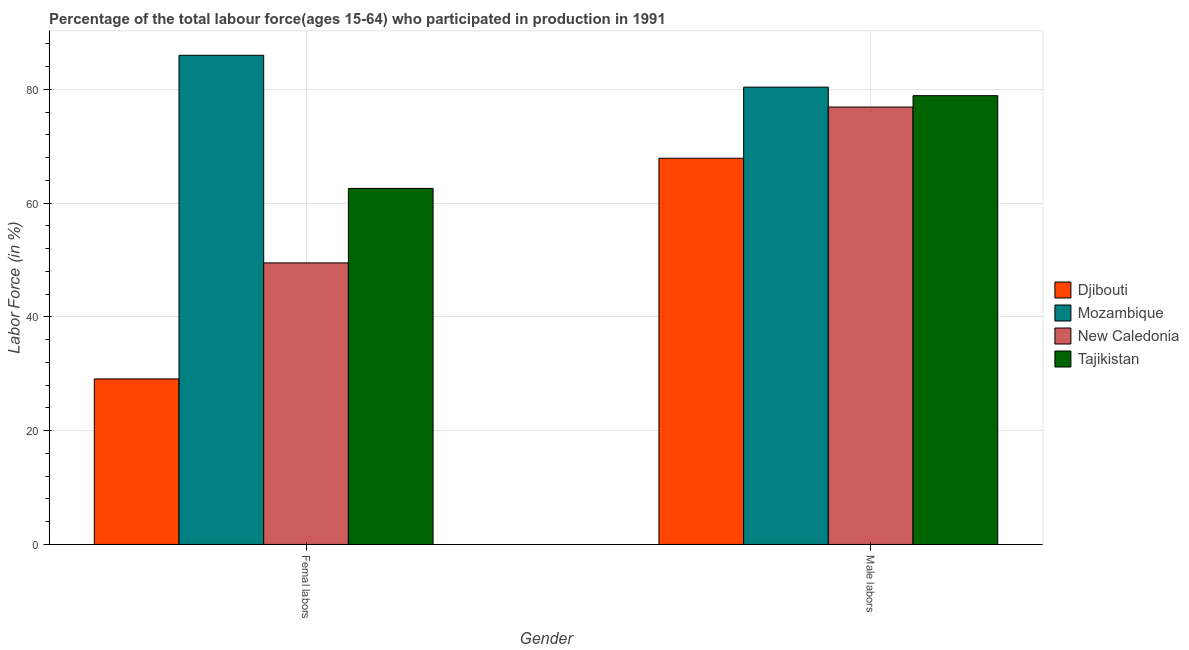How many different coloured bars are there?
Make the answer very short. 4. Are the number of bars on each tick of the X-axis equal?
Offer a terse response. Yes. How many bars are there on the 2nd tick from the right?
Your response must be concise. 4. What is the label of the 2nd group of bars from the left?
Your response must be concise. Male labors. What is the percentage of female labor force in Mozambique?
Provide a succinct answer. 86. Across all countries, what is the maximum percentage of female labor force?
Ensure brevity in your answer.  86. Across all countries, what is the minimum percentage of male labour force?
Provide a succinct answer. 67.9. In which country was the percentage of male labour force maximum?
Provide a succinct answer. Mozambique. In which country was the percentage of male labour force minimum?
Provide a succinct answer. Djibouti. What is the total percentage of male labour force in the graph?
Your answer should be very brief. 304.1. What is the difference between the percentage of female labor force in Tajikistan and that in Djibouti?
Provide a short and direct response. 33.5. What is the difference between the percentage of male labour force in New Caledonia and the percentage of female labor force in Mozambique?
Your response must be concise. -9.1. What is the average percentage of male labour force per country?
Give a very brief answer. 76.03. What is the difference between the percentage of female labor force and percentage of male labour force in Mozambique?
Your response must be concise. 5.6. What is the ratio of the percentage of female labor force in Mozambique to that in Tajikistan?
Offer a terse response. 1.37. Is the percentage of female labor force in Djibouti less than that in New Caledonia?
Keep it short and to the point. Yes. In how many countries, is the percentage of female labor force greater than the average percentage of female labor force taken over all countries?
Offer a terse response. 2. What does the 4th bar from the left in Male labors represents?
Give a very brief answer. Tajikistan. What does the 3rd bar from the right in Male labors represents?
Offer a terse response. Mozambique. How many countries are there in the graph?
Ensure brevity in your answer.  4. Are the values on the major ticks of Y-axis written in scientific E-notation?
Offer a terse response. No. Does the graph contain any zero values?
Your answer should be compact. No. Does the graph contain grids?
Make the answer very short. Yes. How are the legend labels stacked?
Ensure brevity in your answer.  Vertical. What is the title of the graph?
Offer a very short reply. Percentage of the total labour force(ages 15-64) who participated in production in 1991. Does "Armenia" appear as one of the legend labels in the graph?
Offer a terse response. No. What is the label or title of the X-axis?
Provide a succinct answer. Gender. What is the Labor Force (in %) in Djibouti in Femal labors?
Give a very brief answer. 29.1. What is the Labor Force (in %) in Mozambique in Femal labors?
Ensure brevity in your answer.  86. What is the Labor Force (in %) of New Caledonia in Femal labors?
Offer a terse response. 49.5. What is the Labor Force (in %) of Tajikistan in Femal labors?
Offer a very short reply. 62.6. What is the Labor Force (in %) of Djibouti in Male labors?
Offer a very short reply. 67.9. What is the Labor Force (in %) in Mozambique in Male labors?
Provide a short and direct response. 80.4. What is the Labor Force (in %) of New Caledonia in Male labors?
Offer a terse response. 76.9. What is the Labor Force (in %) of Tajikistan in Male labors?
Your response must be concise. 78.9. Across all Gender, what is the maximum Labor Force (in %) in Djibouti?
Provide a short and direct response. 67.9. Across all Gender, what is the maximum Labor Force (in %) in Mozambique?
Provide a succinct answer. 86. Across all Gender, what is the maximum Labor Force (in %) of New Caledonia?
Provide a short and direct response. 76.9. Across all Gender, what is the maximum Labor Force (in %) in Tajikistan?
Your answer should be very brief. 78.9. Across all Gender, what is the minimum Labor Force (in %) in Djibouti?
Provide a succinct answer. 29.1. Across all Gender, what is the minimum Labor Force (in %) in Mozambique?
Give a very brief answer. 80.4. Across all Gender, what is the minimum Labor Force (in %) of New Caledonia?
Your response must be concise. 49.5. Across all Gender, what is the minimum Labor Force (in %) of Tajikistan?
Your response must be concise. 62.6. What is the total Labor Force (in %) of Djibouti in the graph?
Offer a terse response. 97. What is the total Labor Force (in %) of Mozambique in the graph?
Your answer should be very brief. 166.4. What is the total Labor Force (in %) in New Caledonia in the graph?
Provide a short and direct response. 126.4. What is the total Labor Force (in %) in Tajikistan in the graph?
Provide a succinct answer. 141.5. What is the difference between the Labor Force (in %) of Djibouti in Femal labors and that in Male labors?
Keep it short and to the point. -38.8. What is the difference between the Labor Force (in %) in Mozambique in Femal labors and that in Male labors?
Ensure brevity in your answer.  5.6. What is the difference between the Labor Force (in %) in New Caledonia in Femal labors and that in Male labors?
Make the answer very short. -27.4. What is the difference between the Labor Force (in %) in Tajikistan in Femal labors and that in Male labors?
Provide a succinct answer. -16.3. What is the difference between the Labor Force (in %) of Djibouti in Femal labors and the Labor Force (in %) of Mozambique in Male labors?
Offer a very short reply. -51.3. What is the difference between the Labor Force (in %) of Djibouti in Femal labors and the Labor Force (in %) of New Caledonia in Male labors?
Offer a very short reply. -47.8. What is the difference between the Labor Force (in %) of Djibouti in Femal labors and the Labor Force (in %) of Tajikistan in Male labors?
Offer a very short reply. -49.8. What is the difference between the Labor Force (in %) of Mozambique in Femal labors and the Labor Force (in %) of Tajikistan in Male labors?
Your answer should be very brief. 7.1. What is the difference between the Labor Force (in %) of New Caledonia in Femal labors and the Labor Force (in %) of Tajikistan in Male labors?
Your response must be concise. -29.4. What is the average Labor Force (in %) of Djibouti per Gender?
Offer a very short reply. 48.5. What is the average Labor Force (in %) in Mozambique per Gender?
Offer a very short reply. 83.2. What is the average Labor Force (in %) in New Caledonia per Gender?
Provide a short and direct response. 63.2. What is the average Labor Force (in %) in Tajikistan per Gender?
Offer a terse response. 70.75. What is the difference between the Labor Force (in %) of Djibouti and Labor Force (in %) of Mozambique in Femal labors?
Give a very brief answer. -56.9. What is the difference between the Labor Force (in %) of Djibouti and Labor Force (in %) of New Caledonia in Femal labors?
Give a very brief answer. -20.4. What is the difference between the Labor Force (in %) of Djibouti and Labor Force (in %) of Tajikistan in Femal labors?
Offer a very short reply. -33.5. What is the difference between the Labor Force (in %) in Mozambique and Labor Force (in %) in New Caledonia in Femal labors?
Your answer should be very brief. 36.5. What is the difference between the Labor Force (in %) of Mozambique and Labor Force (in %) of Tajikistan in Femal labors?
Your answer should be very brief. 23.4. What is the difference between the Labor Force (in %) in New Caledonia and Labor Force (in %) in Tajikistan in Femal labors?
Offer a very short reply. -13.1. What is the difference between the Labor Force (in %) of Djibouti and Labor Force (in %) of Mozambique in Male labors?
Your response must be concise. -12.5. What is the difference between the Labor Force (in %) in Djibouti and Labor Force (in %) in Tajikistan in Male labors?
Make the answer very short. -11. What is the ratio of the Labor Force (in %) in Djibouti in Femal labors to that in Male labors?
Ensure brevity in your answer.  0.43. What is the ratio of the Labor Force (in %) of Mozambique in Femal labors to that in Male labors?
Give a very brief answer. 1.07. What is the ratio of the Labor Force (in %) in New Caledonia in Femal labors to that in Male labors?
Make the answer very short. 0.64. What is the ratio of the Labor Force (in %) in Tajikistan in Femal labors to that in Male labors?
Your answer should be very brief. 0.79. What is the difference between the highest and the second highest Labor Force (in %) in Djibouti?
Give a very brief answer. 38.8. What is the difference between the highest and the second highest Labor Force (in %) of Mozambique?
Offer a terse response. 5.6. What is the difference between the highest and the second highest Labor Force (in %) of New Caledonia?
Give a very brief answer. 27.4. What is the difference between the highest and the second highest Labor Force (in %) in Tajikistan?
Your answer should be compact. 16.3. What is the difference between the highest and the lowest Labor Force (in %) in Djibouti?
Your answer should be very brief. 38.8. What is the difference between the highest and the lowest Labor Force (in %) in Mozambique?
Ensure brevity in your answer.  5.6. What is the difference between the highest and the lowest Labor Force (in %) of New Caledonia?
Your answer should be very brief. 27.4. What is the difference between the highest and the lowest Labor Force (in %) of Tajikistan?
Keep it short and to the point. 16.3. 